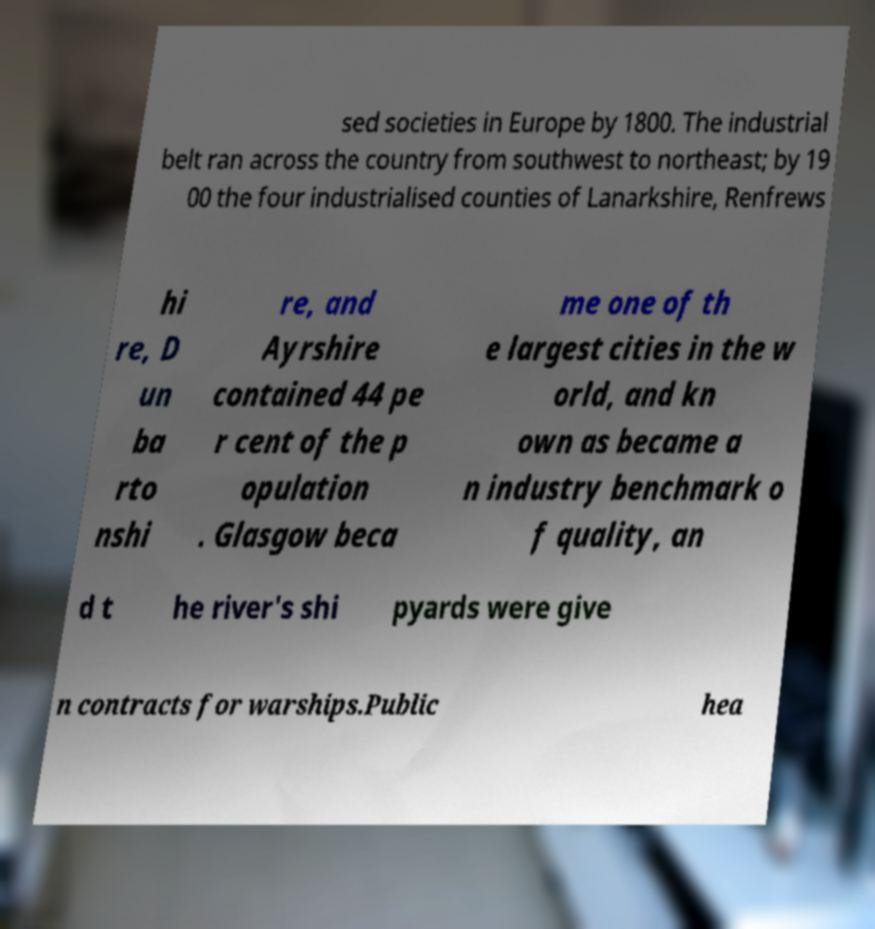Could you assist in decoding the text presented in this image and type it out clearly? sed societies in Europe by 1800. The industrial belt ran across the country from southwest to northeast; by 19 00 the four industrialised counties of Lanarkshire, Renfrews hi re, D un ba rto nshi re, and Ayrshire contained 44 pe r cent of the p opulation . Glasgow beca me one of th e largest cities in the w orld, and kn own as became a n industry benchmark o f quality, an d t he river's shi pyards were give n contracts for warships.Public hea 